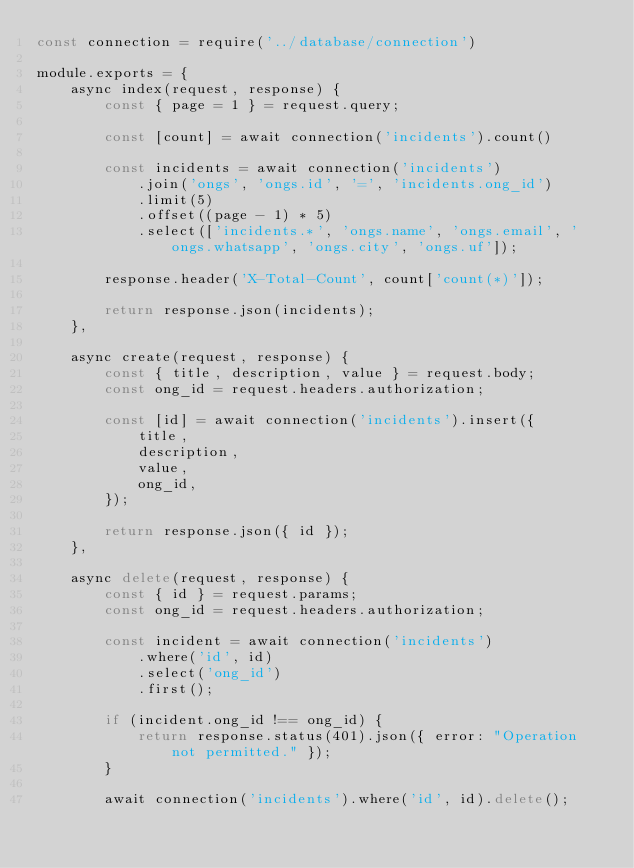Convert code to text. <code><loc_0><loc_0><loc_500><loc_500><_JavaScript_>const connection = require('../database/connection')

module.exports = {
    async index(request, response) {
        const { page = 1 } = request.query;

        const [count] = await connection('incidents').count()

        const incidents = await connection('incidents')
            .join('ongs', 'ongs.id', '=', 'incidents.ong_id')
            .limit(5)
            .offset((page - 1) * 5)
            .select(['incidents.*', 'ongs.name', 'ongs.email', 'ongs.whatsapp', 'ongs.city', 'ongs.uf']);

        response.header('X-Total-Count', count['count(*)']);

        return response.json(incidents);
    },

    async create(request, response) {
        const { title, description, value } = request.body;
        const ong_id = request.headers.authorization;

        const [id] = await connection('incidents').insert({
            title,
            description,
            value,
            ong_id,
        });

        return response.json({ id });
    },

    async delete(request, response) {
        const { id } = request.params;
        const ong_id = request.headers.authorization;

        const incident = await connection('incidents')
            .where('id', id)
            .select('ong_id')
            .first();

        if (incident.ong_id !== ong_id) {
            return response.status(401).json({ error: "Operation not permitted." });
        }

        await connection('incidents').where('id', id).delete();
</code> 